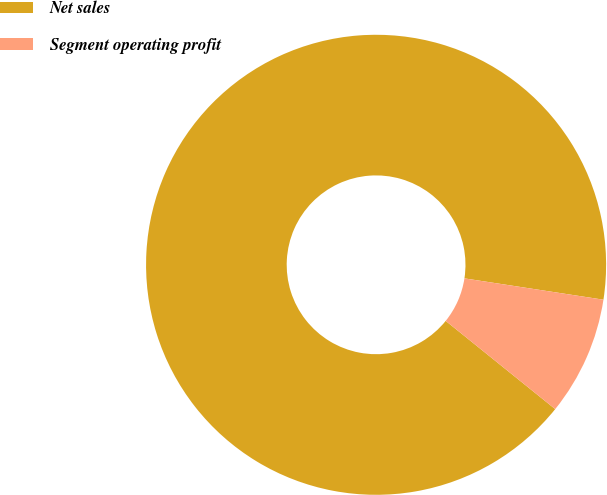Convert chart to OTSL. <chart><loc_0><loc_0><loc_500><loc_500><pie_chart><fcel>Net sales<fcel>Segment operating profit<nl><fcel>91.63%<fcel>8.37%<nl></chart> 